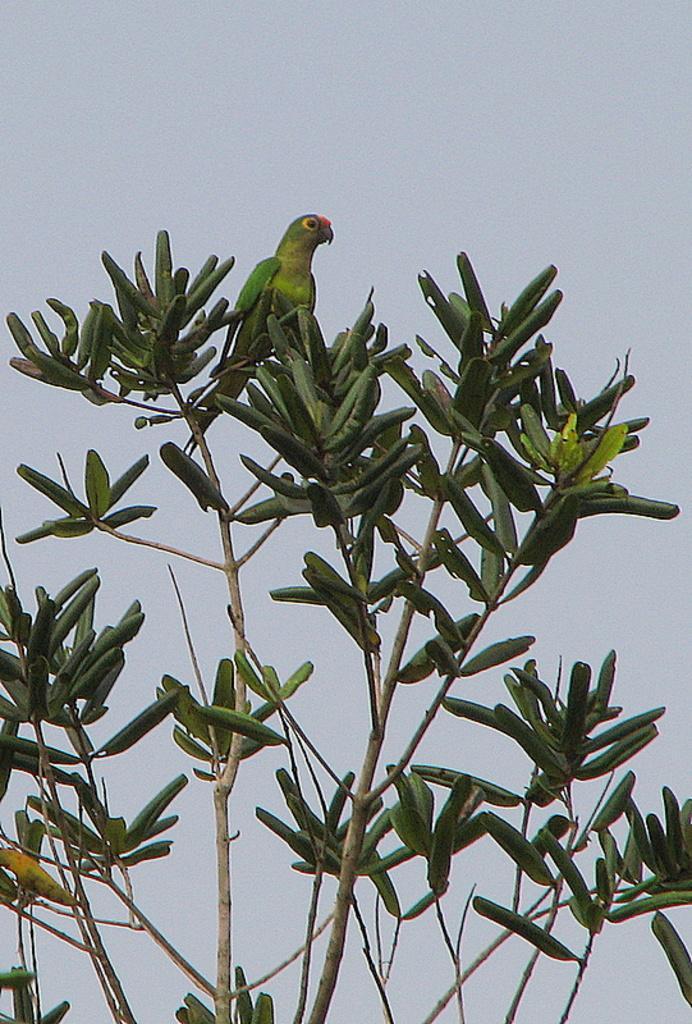How would you summarize this image in a sentence or two? Here we can see a parrot on a tree and in the background we can see sky. 